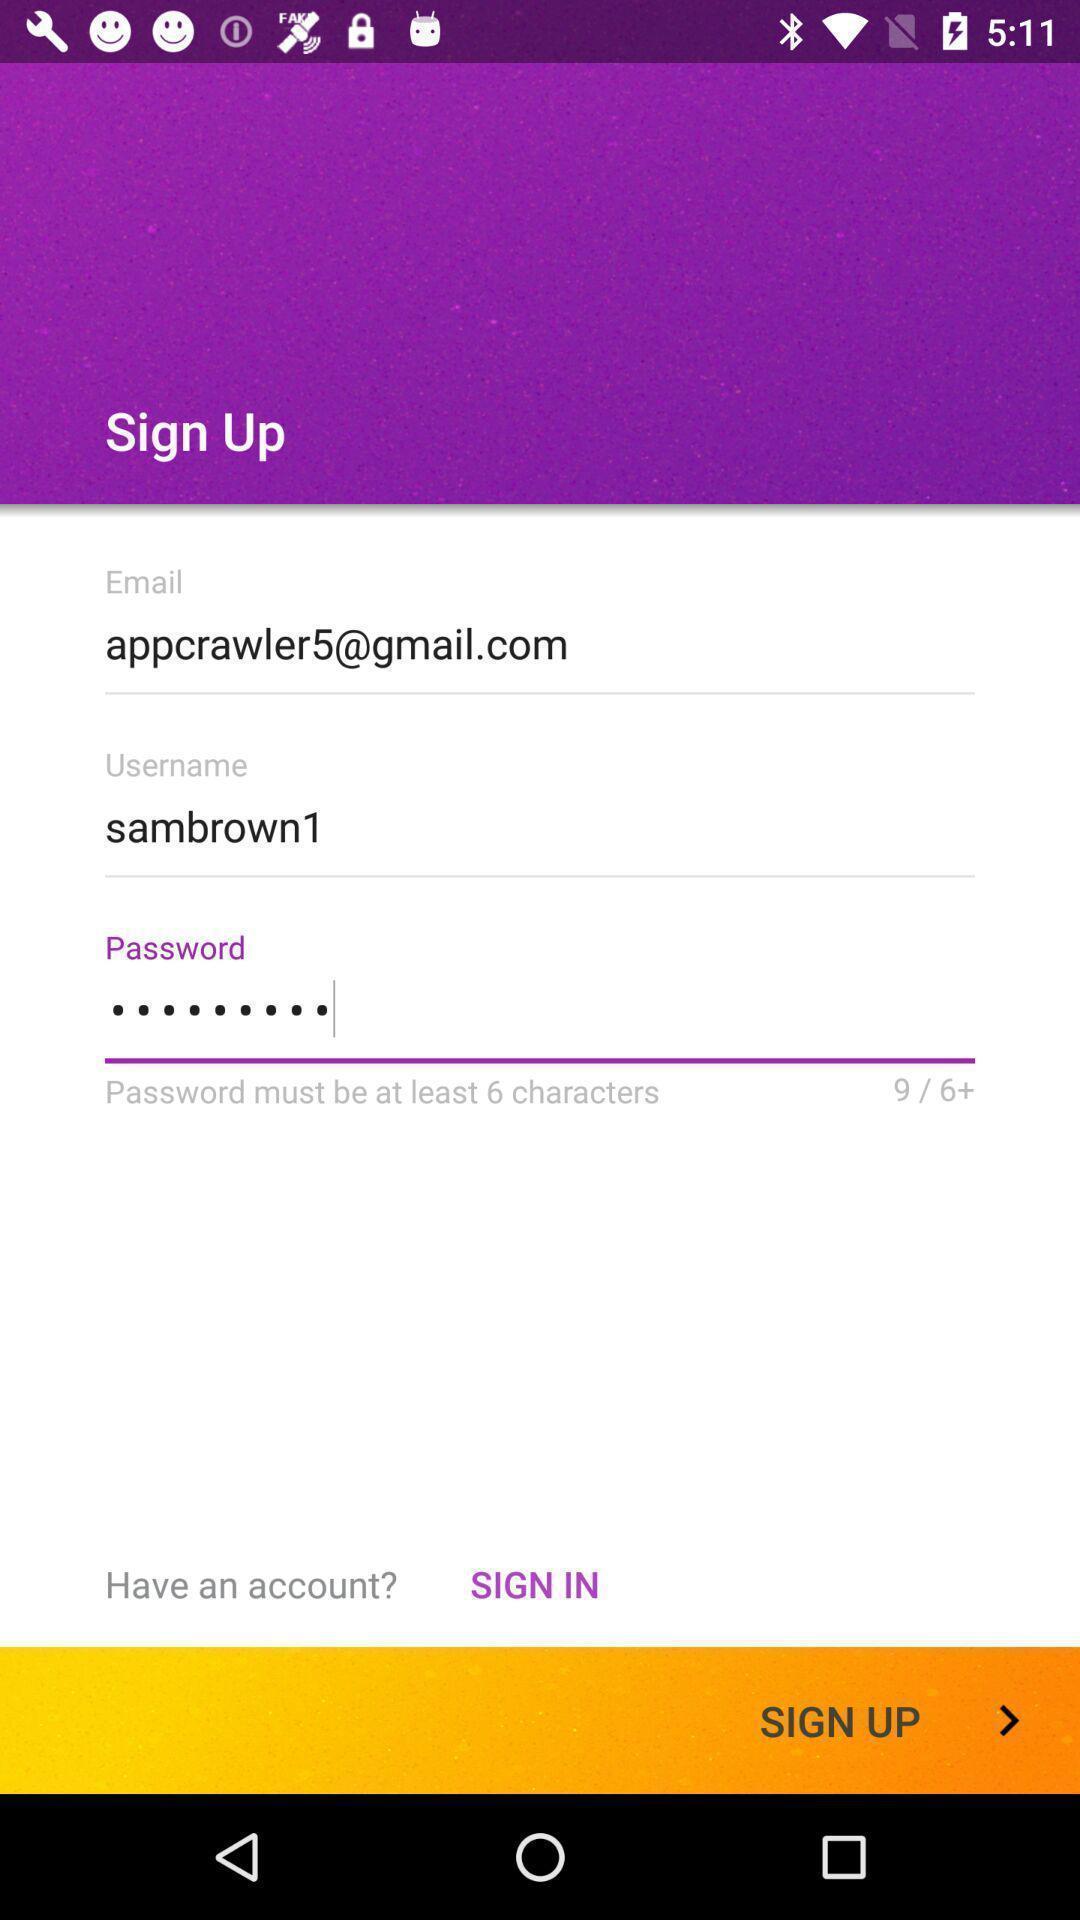Provide a description of this screenshot. Signup page in a music app. 